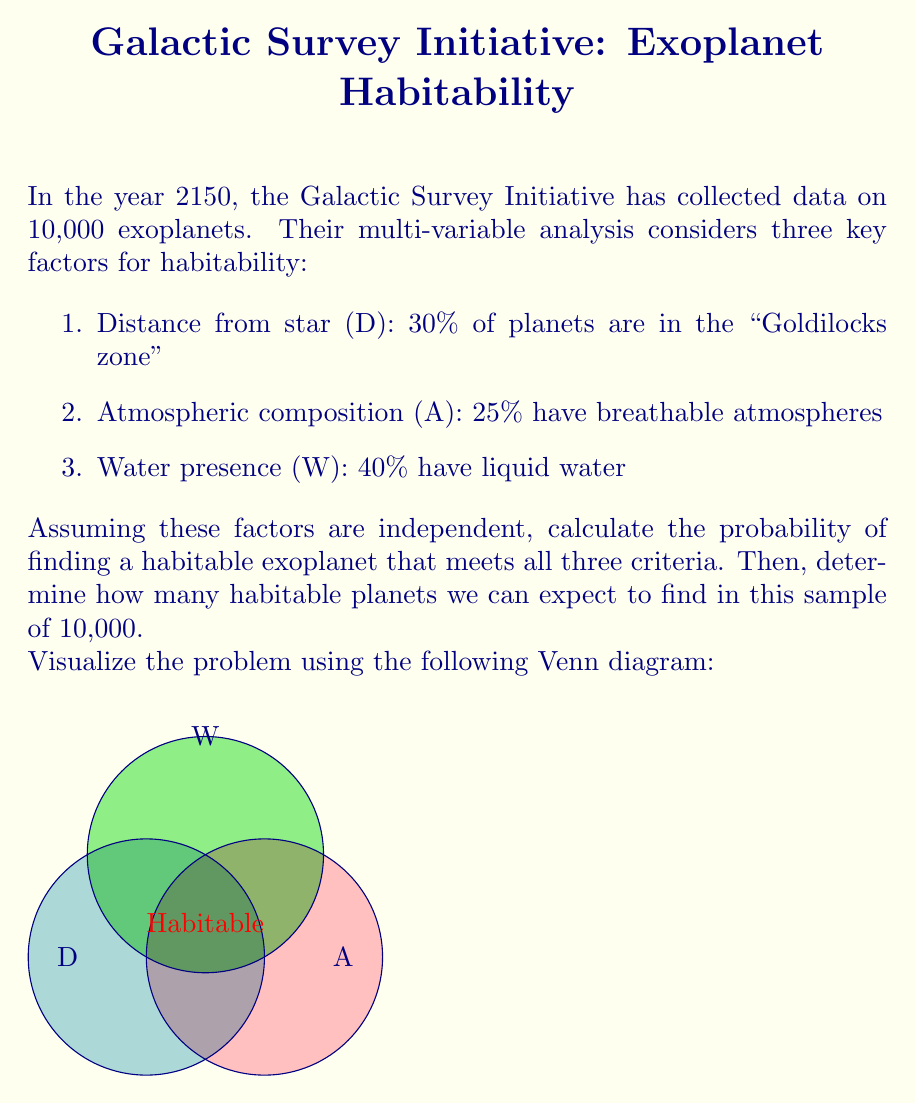Show me your answer to this math problem. Let's approach this step-by-step:

1) First, we need to calculate the probability of a planet meeting all three criteria. Since the events are independent, we multiply the individual probabilities:

   $P(\text{Habitable}) = P(D) \times P(A) \times P(W)$

2) Substituting the given probabilities:

   $P(\text{Habitable}) = 0.30 \times 0.25 \times 0.40$

3) Calculating:

   $P(\text{Habitable}) = 0.03$ or 3%

4) Now, to determine the expected number of habitable planets in the sample, we multiply the probability by the total number of planets:

   $\text{Expected number} = P(\text{Habitable}) \times \text{Total planets}$

5) Substituting the values:

   $\text{Expected number} = 0.03 \times 10,000 = 300$

Therefore, we can expect to find 300 habitable planets in this sample of 10,000 exoplanets.

This problem demonstrates how multi-variable analysis can be used to estimate the occurrence of habitable exoplanets, a crucial aspect of exoplanet research and the search for extraterrestrial life.
Answer: 300 habitable planets 